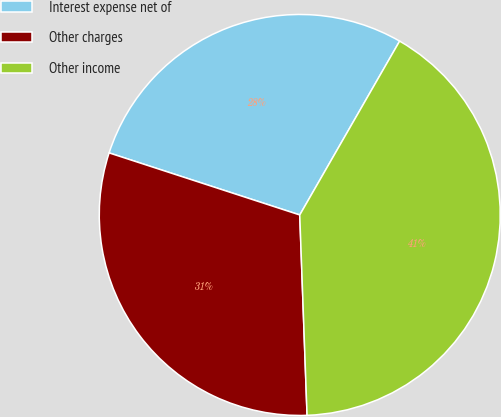<chart> <loc_0><loc_0><loc_500><loc_500><pie_chart><fcel>Interest expense net of<fcel>Other charges<fcel>Other income<nl><fcel>28.29%<fcel>30.59%<fcel>41.12%<nl></chart> 